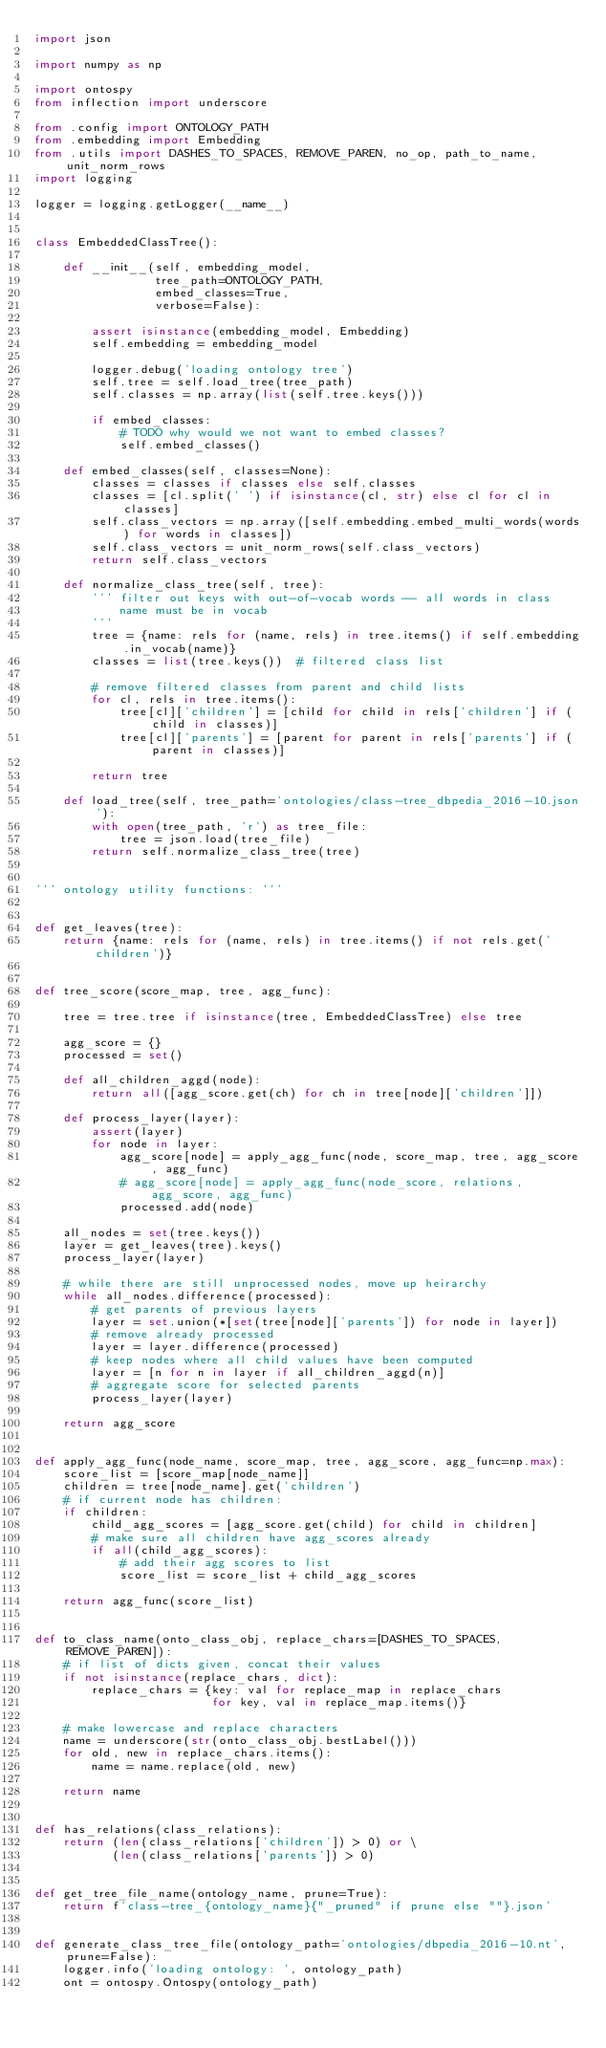Convert code to text. <code><loc_0><loc_0><loc_500><loc_500><_Python_>import json

import numpy as np

import ontospy
from inflection import underscore

from .config import ONTOLOGY_PATH
from .embedding import Embedding
from .utils import DASHES_TO_SPACES, REMOVE_PAREN, no_op, path_to_name, unit_norm_rows
import logging

logger = logging.getLogger(__name__)


class EmbeddedClassTree():

    def __init__(self, embedding_model,
                 tree_path=ONTOLOGY_PATH,
                 embed_classes=True,
                 verbose=False):

        assert isinstance(embedding_model, Embedding)
        self.embedding = embedding_model

        logger.debug('loading ontology tree')
        self.tree = self.load_tree(tree_path)
        self.classes = np.array(list(self.tree.keys()))

        if embed_classes:
            # TODO why would we not want to embed classes?
            self.embed_classes()

    def embed_classes(self, classes=None):
        classes = classes if classes else self.classes
        classes = [cl.split(' ') if isinstance(cl, str) else cl for cl in classes]
        self.class_vectors = np.array([self.embedding.embed_multi_words(words) for words in classes])
        self.class_vectors = unit_norm_rows(self.class_vectors)
        return self.class_vectors

    def normalize_class_tree(self, tree):
        ''' filter out keys with out-of-vocab words -- all words in class 
            name must be in vocab
        '''
        tree = {name: rels for (name, rels) in tree.items() if self.embedding.in_vocab(name)}
        classes = list(tree.keys())  # filtered class list

        # remove filtered classes from parent and child lists
        for cl, rels in tree.items():
            tree[cl]['children'] = [child for child in rels['children'] if (child in classes)]
            tree[cl]['parents'] = [parent for parent in rels['parents'] if (parent in classes)]

        return tree

    def load_tree(self, tree_path='ontologies/class-tree_dbpedia_2016-10.json'):
        with open(tree_path, 'r') as tree_file:
            tree = json.load(tree_file)
        return self.normalize_class_tree(tree)


''' ontology utility functions: '''


def get_leaves(tree):
    return {name: rels for (name, rels) in tree.items() if not rels.get('children')}


def tree_score(score_map, tree, agg_func):

    tree = tree.tree if isinstance(tree, EmbeddedClassTree) else tree

    agg_score = {}
    processed = set()

    def all_children_aggd(node):
        return all([agg_score.get(ch) for ch in tree[node]['children']])

    def process_layer(layer):
        assert(layer)
        for node in layer:
            agg_score[node] = apply_agg_func(node, score_map, tree, agg_score, agg_func)
            # agg_score[node] = apply_agg_func(node_score, relations, agg_score, agg_func)
            processed.add(node)

    all_nodes = set(tree.keys())
    layer = get_leaves(tree).keys()
    process_layer(layer)

    # while there are still unprocessed nodes, move up heirarchy
    while all_nodes.difference(processed):
        # get parents of previous layers
        layer = set.union(*[set(tree[node]['parents']) for node in layer])
        # remove already processed
        layer = layer.difference(processed)
        # keep nodes where all child values have been computed
        layer = [n for n in layer if all_children_aggd(n)]
        # aggregate score for selected parents
        process_layer(layer)

    return agg_score


def apply_agg_func(node_name, score_map, tree, agg_score, agg_func=np.max):
    score_list = [score_map[node_name]]
    children = tree[node_name].get('children')
    # if current node has children:
    if children:
        child_agg_scores = [agg_score.get(child) for child in children]
        # make sure all children have agg_scores already
        if all(child_agg_scores):
            # add their agg scores to list
            score_list = score_list + child_agg_scores

    return agg_func(score_list)


def to_class_name(onto_class_obj, replace_chars=[DASHES_TO_SPACES, REMOVE_PAREN]):
    # if list of dicts given, concat their values
    if not isinstance(replace_chars, dict):
        replace_chars = {key: val for replace_map in replace_chars
                         for key, val in replace_map.items()}

    # make lowercase and replace characters
    name = underscore(str(onto_class_obj.bestLabel()))
    for old, new in replace_chars.items():
        name = name.replace(old, new)

    return name


def has_relations(class_relations):
    return (len(class_relations['children']) > 0) or \
           (len(class_relations['parents']) > 0)


def get_tree_file_name(ontology_name, prune=True):
    return f'class-tree_{ontology_name}{"_pruned" if prune else ""}.json'


def generate_class_tree_file(ontology_path='ontologies/dbpedia_2016-10.nt', prune=False):
    logger.info('loading ontology: ', ontology_path)
    ont = ontospy.Ontospy(ontology_path)
</code> 